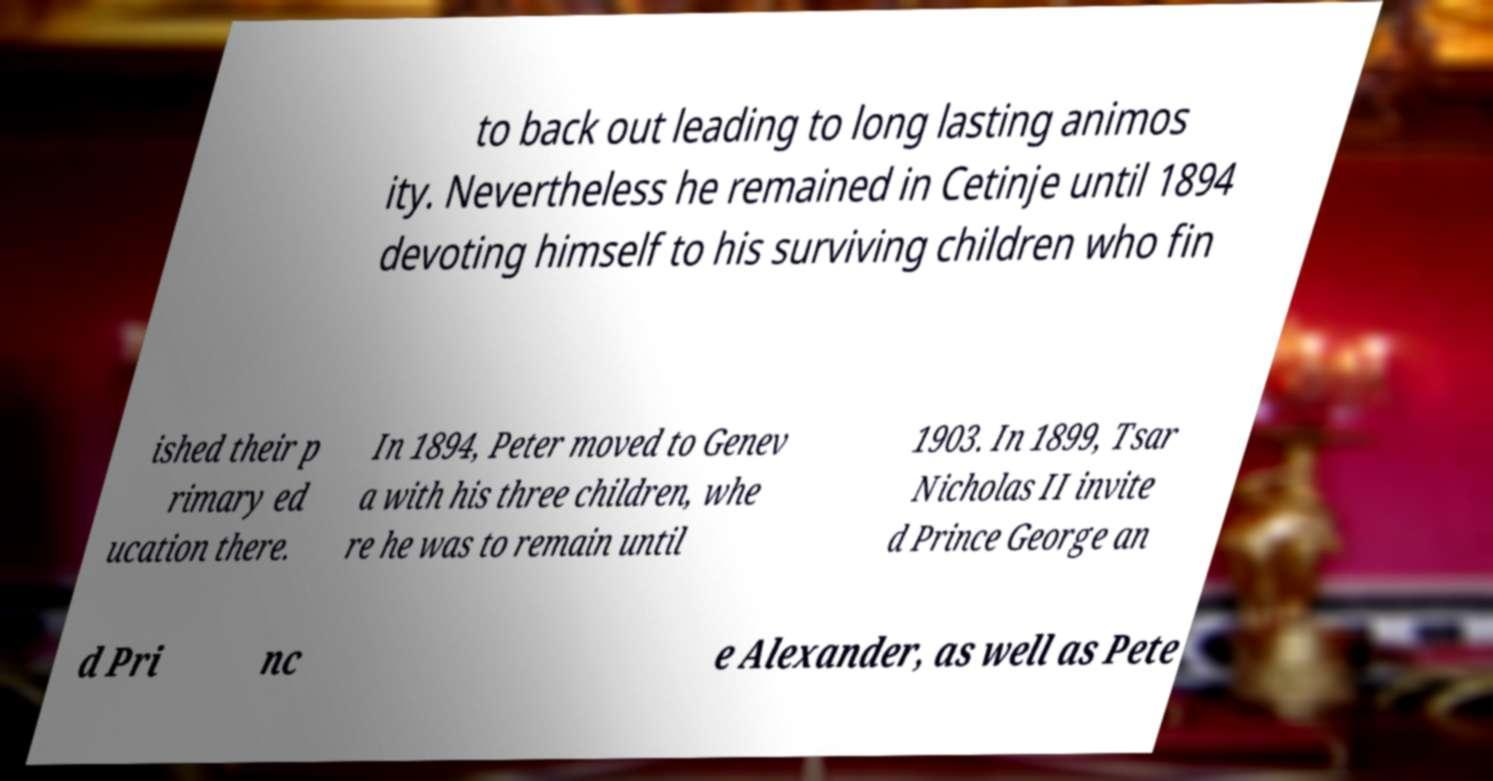I need the written content from this picture converted into text. Can you do that? to back out leading to long lasting animos ity. Nevertheless he remained in Cetinje until 1894 devoting himself to his surviving children who fin ished their p rimary ed ucation there. In 1894, Peter moved to Genev a with his three children, whe re he was to remain until 1903. In 1899, Tsar Nicholas II invite d Prince George an d Pri nc e Alexander, as well as Pete 